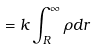Convert formula to latex. <formula><loc_0><loc_0><loc_500><loc_500>= k \int _ { R } ^ { \infty } \rho d r</formula> 